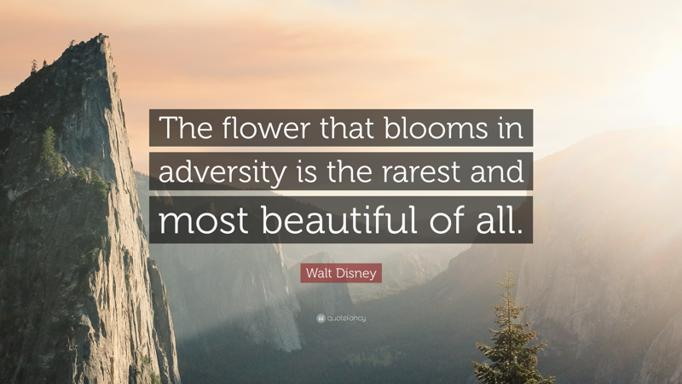Is the mountain scenery in the image related to the quote? Yes, the mountainous backdrop in the image serves as a powerful visual metaphor for the quote. Mountains, inherently tough terrains, symbolize significant life challenges. Climbing a mountain, much like navigating life's hurdles, demands resilience and strength. In overcoming these, one not only achieves new heights but also grows in character and beauty, much like the 'flower' in Walt Disney's quote that thrives in adversity. 